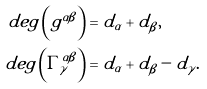Convert formula to latex. <formula><loc_0><loc_0><loc_500><loc_500>d e g \left ( g ^ { \alpha \beta } \right ) & = d _ { \alpha } + d _ { \beta } , \\ d e g \left ( \Gamma _ { \gamma } ^ { \alpha \beta } \right ) & = d _ { \alpha } + d _ { \beta } - d _ { \gamma } . \\</formula> 